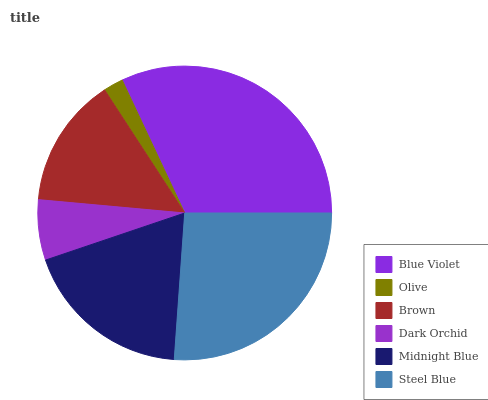Is Olive the minimum?
Answer yes or no. Yes. Is Blue Violet the maximum?
Answer yes or no. Yes. Is Brown the minimum?
Answer yes or no. No. Is Brown the maximum?
Answer yes or no. No. Is Brown greater than Olive?
Answer yes or no. Yes. Is Olive less than Brown?
Answer yes or no. Yes. Is Olive greater than Brown?
Answer yes or no. No. Is Brown less than Olive?
Answer yes or no. No. Is Midnight Blue the high median?
Answer yes or no. Yes. Is Brown the low median?
Answer yes or no. Yes. Is Brown the high median?
Answer yes or no. No. Is Olive the low median?
Answer yes or no. No. 